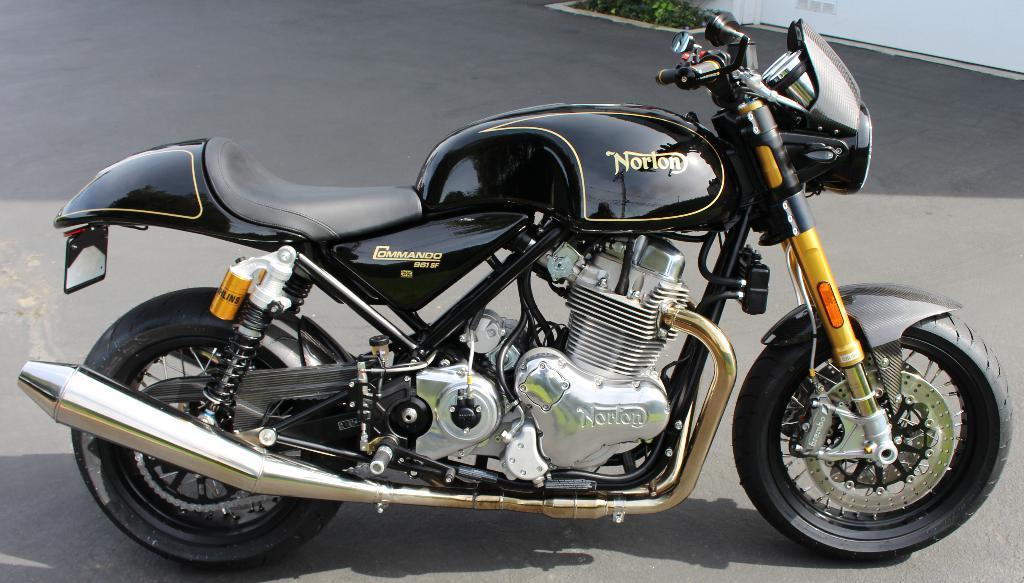Please provide a concise description of this image. This picture contains a bike which is parked on the road. This bike is in black color. In the right top of the picture, we see plants and a wall in white color. 